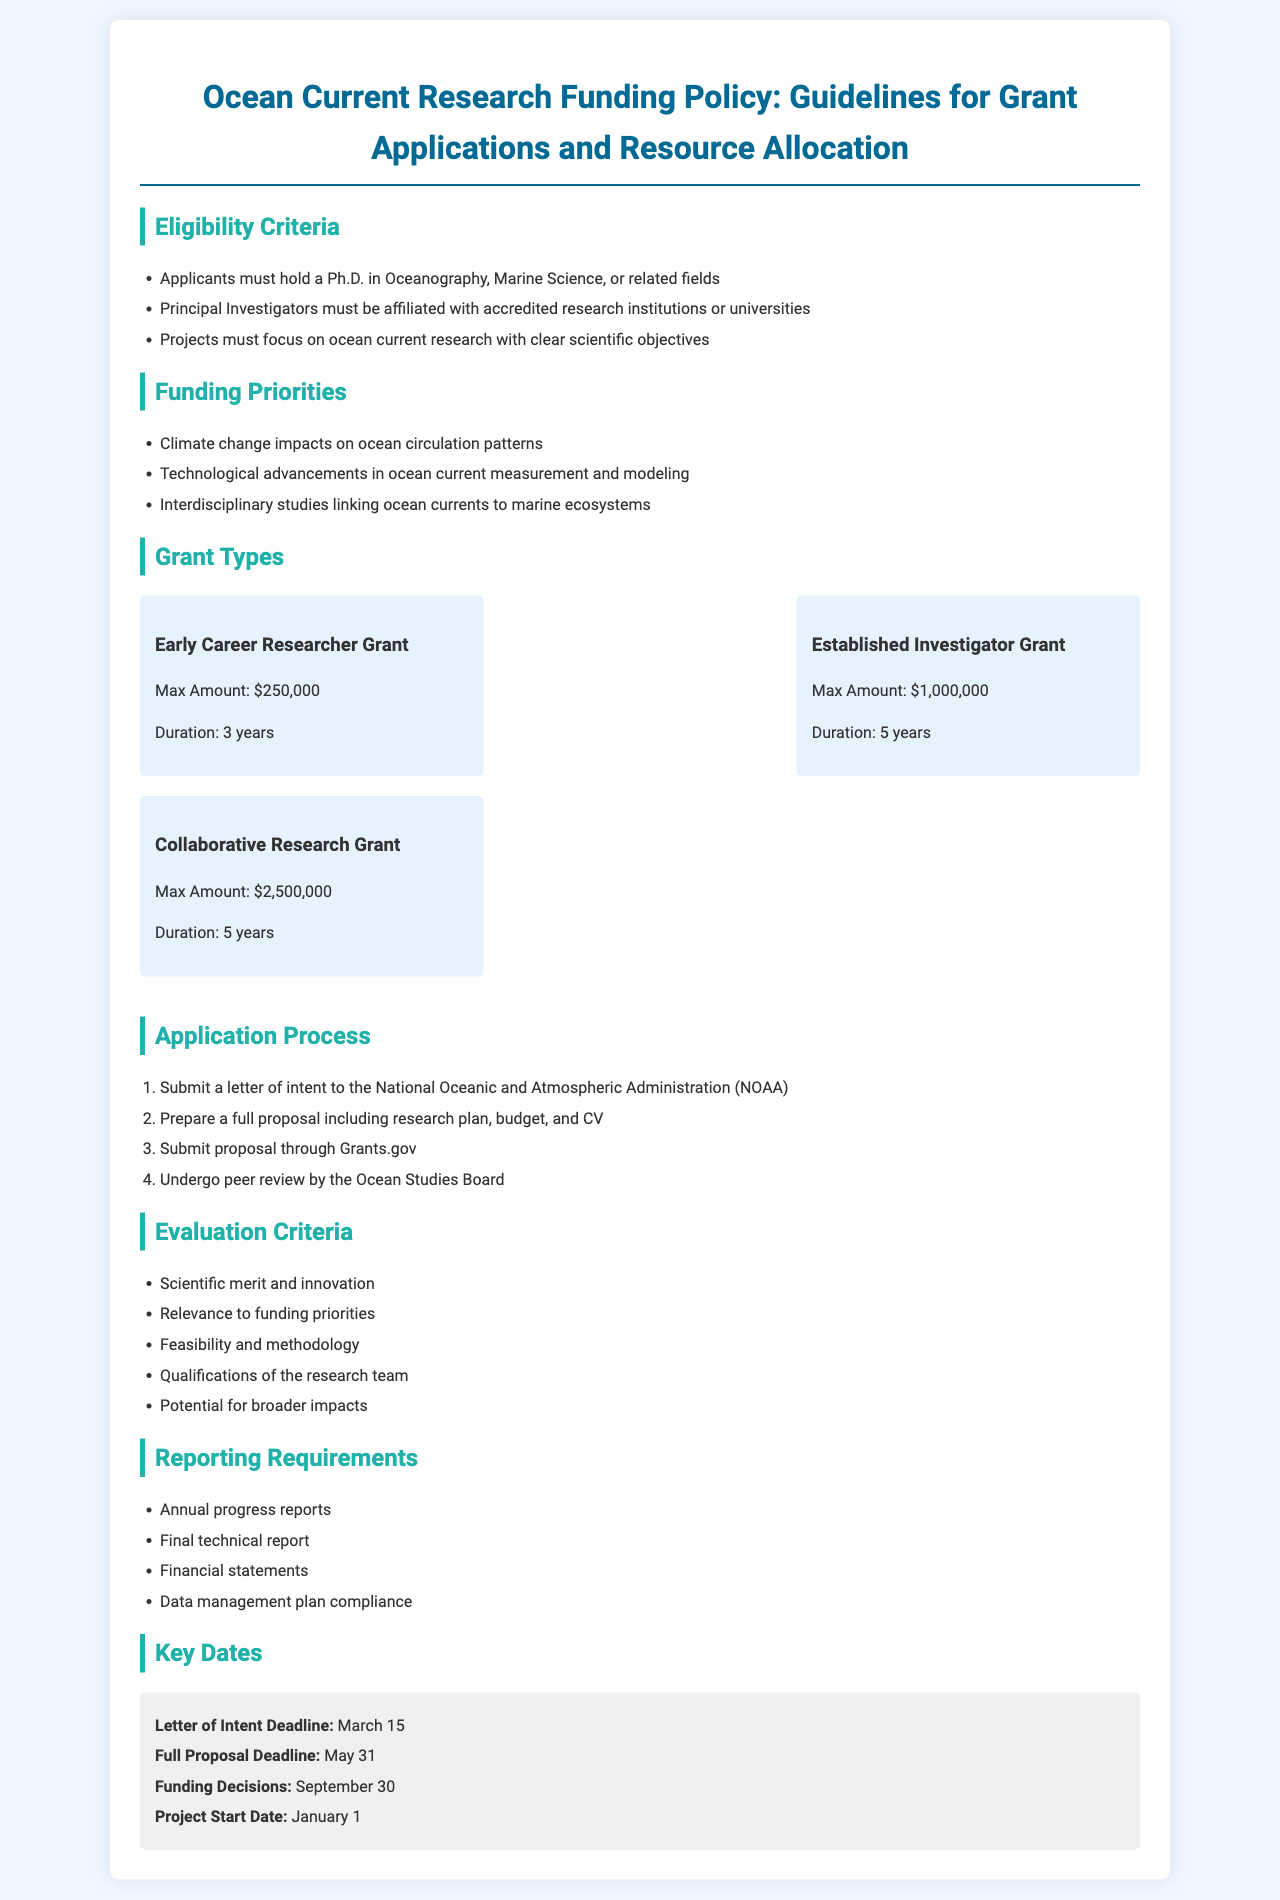What is the maximum amount for the Early Career Researcher Grant? The maximum amount for the Early Career Researcher Grant is specified in the grant types section under funding details.
Answer: $250,000 What is the deadline for submitting the Letter of Intent? The document lists key dates, including the deadline for submitting the Letter of Intent.
Answer: March 15 Which organization must the proposals be submitted to? The application process section states the organization that proposals must be submitted to.
Answer: National Oceanic and Atmospheric Administration (NOAA) How many criteria are there for evaluation? The evaluation criteria section lists the factors considered for evaluating proposals, which can be counted for this answer.
Answer: 5 What is one funding priority related to climate change? The funding priorities mention specific areas related to ocean current research, including climate change.
Answer: Climate change impacts on ocean circulation patterns What is the duration of the Established Investigator Grant? The duration for the Established Investigator Grant is outlined in the grant types section.
Answer: 5 years What must be included in the full proposal? The application process specifies the components required in the full proposal.
Answer: Research plan, budget, and CV What report is due at the end of the project? The reporting requirements detail the types of reports needed after completing the project.
Answer: Final technical report 